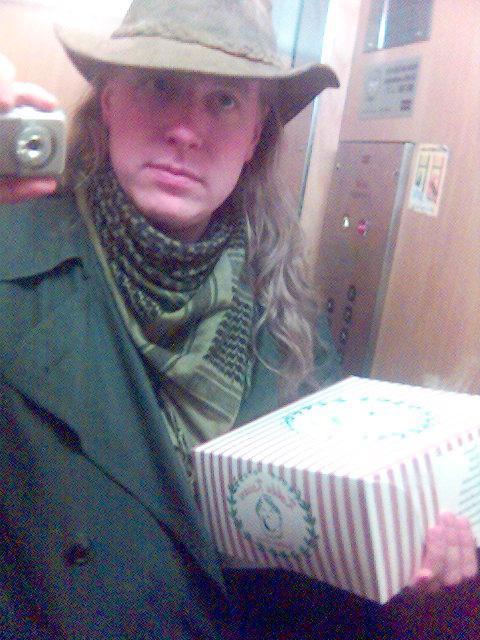How many elephants are near the rocks?
Give a very brief answer. 0. 